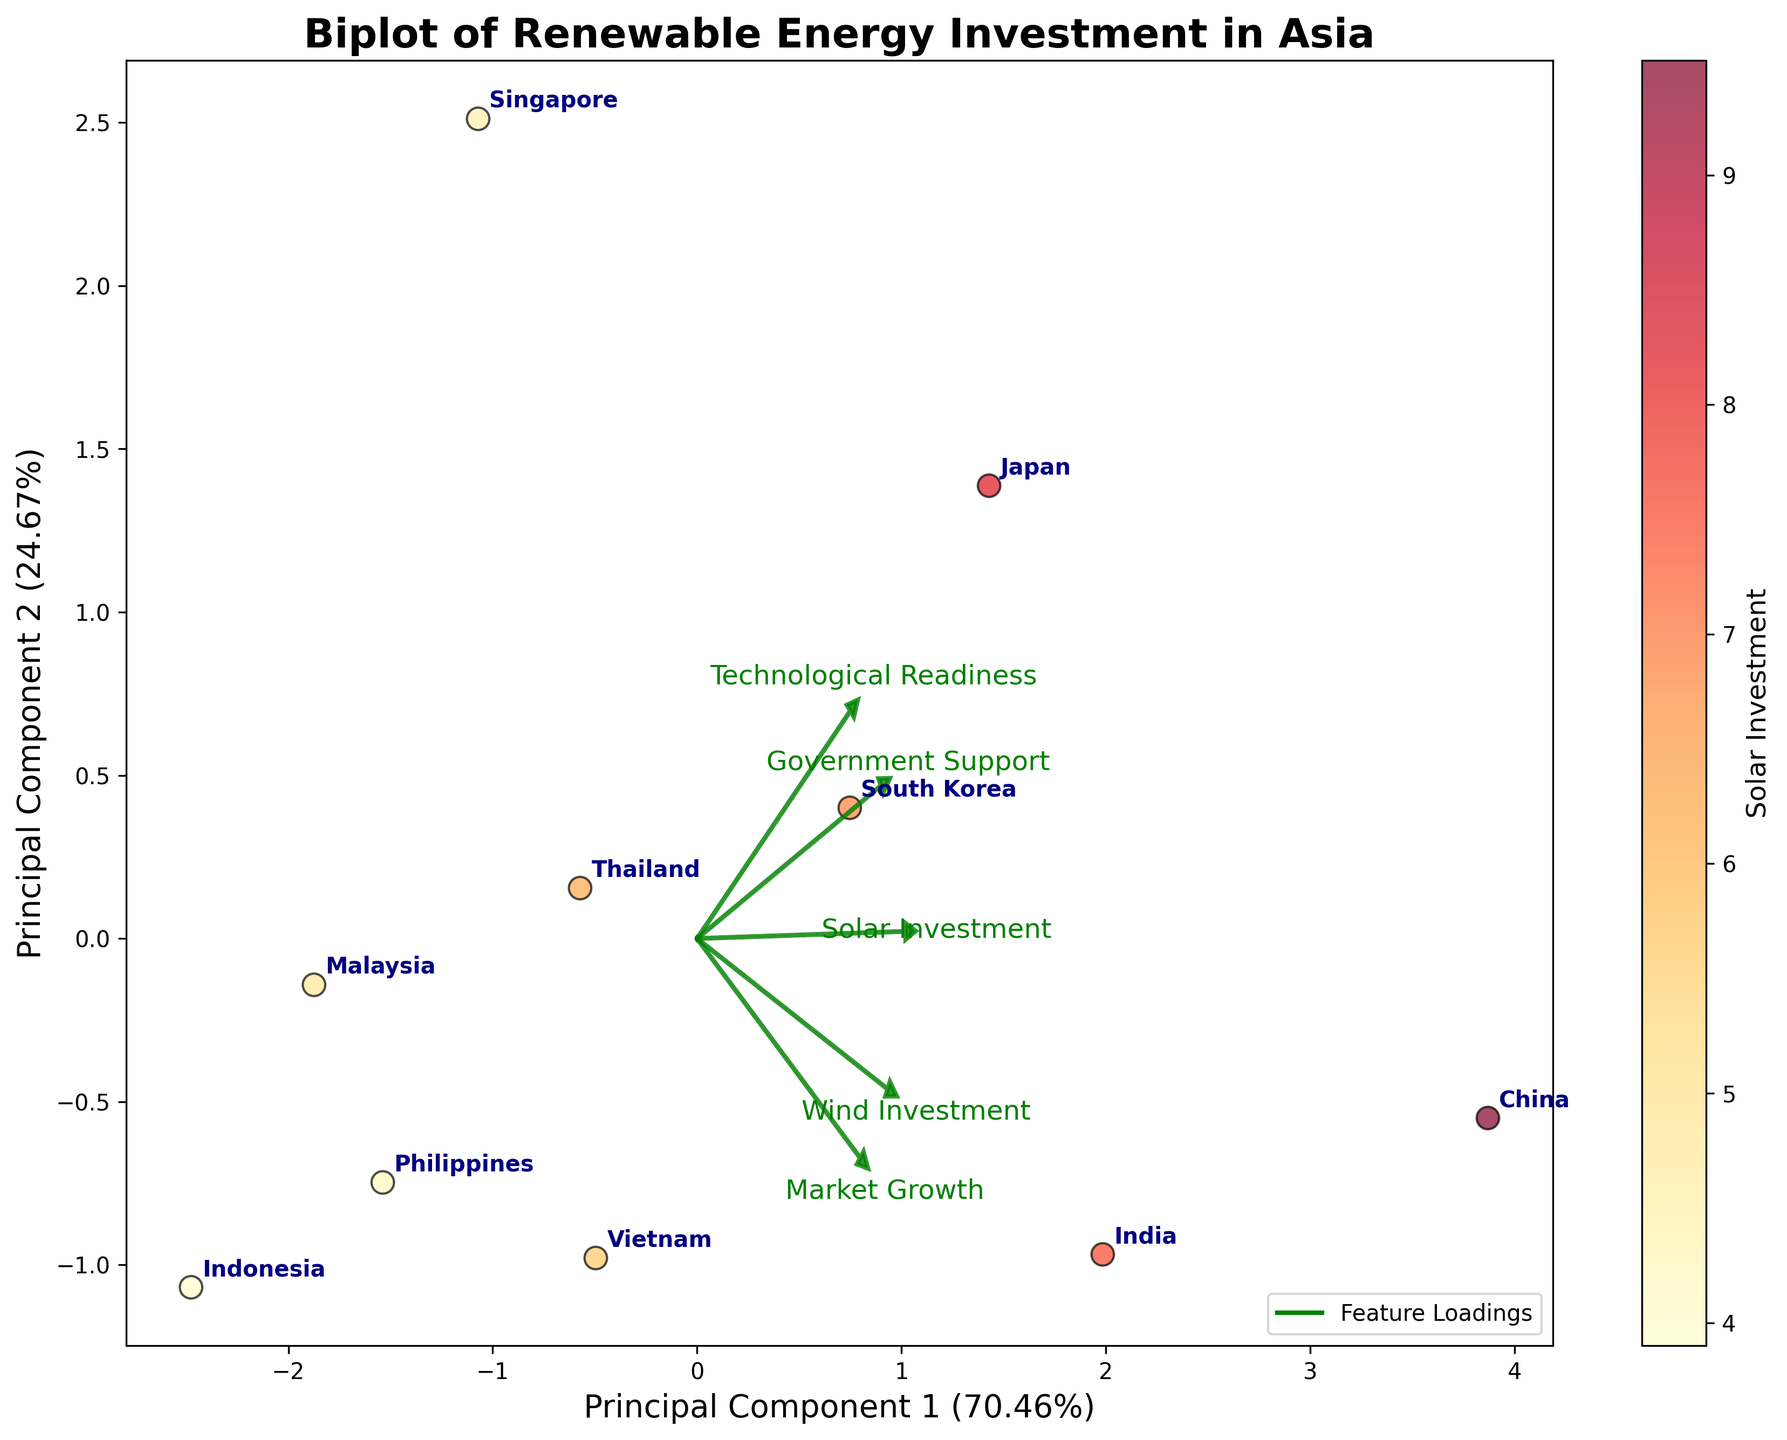Which country has the highest Solar Investment? By looking at the color gradient of the scatter points, China has the darkest shade, indicating the highest Solar Investment.
Answer: China Which country is closest to the origin in the biplot? By observing the scatter plot and the labeling, Indonesia appears to be the closest to the origin (0,0).
Answer: Indonesia How does Japan compare to India in terms of technological readiness and wind investment? Assessing the direction and length of the loadings for Technological Readiness and Wind Investment, and the positions of the scatter points, Japan scores higher in Technological Readiness, while India invests more in Wind Investment.
Answer: Japan is higher in Technological Readiness, India is higher in Wind Investment Between South Korea and Vietnam, which country has higher government support for renewable energy? Analyzing the positioning relative to the arrow indicating Government Support, South Korea appears to be closer to the direction of high government support.
Answer: South Korea What is the principal component that explains the most variance in the data, and how much does it explain? The first principal component (PC1) on the x-axis explains the most variance, as indicated by its labeling and the length of the associated loadings. The percentage explained by PC1 is noted on the axis label.
Answer: PC1 explains the most variance at 52.3% Are there any countries with a similar investment pattern in Solar and Wind energy? By examining the proximity of countries to each other in the biplot and their alignment along the Solar and Wind Investment loadings, South Korea and Thailand show similarities in their investment patterns relative to other countries.
Answer: South Korea and Thailand Which features contribute the most to the first principal component (PC1)? The direction and length of the loading vectors indicate that Solar Investment and Wind Investment vectors are longest and closest to the direction of PC1, thus contributing most to it.
Answer: Solar Investment and Wind Investment Which country shows the least alignment with Market Growth? The country's position relative to the Market Growth loading vector indicates that Singapore shows the least alignment as it is positioned the furthest opposed to this vector.
Answer: Singapore 